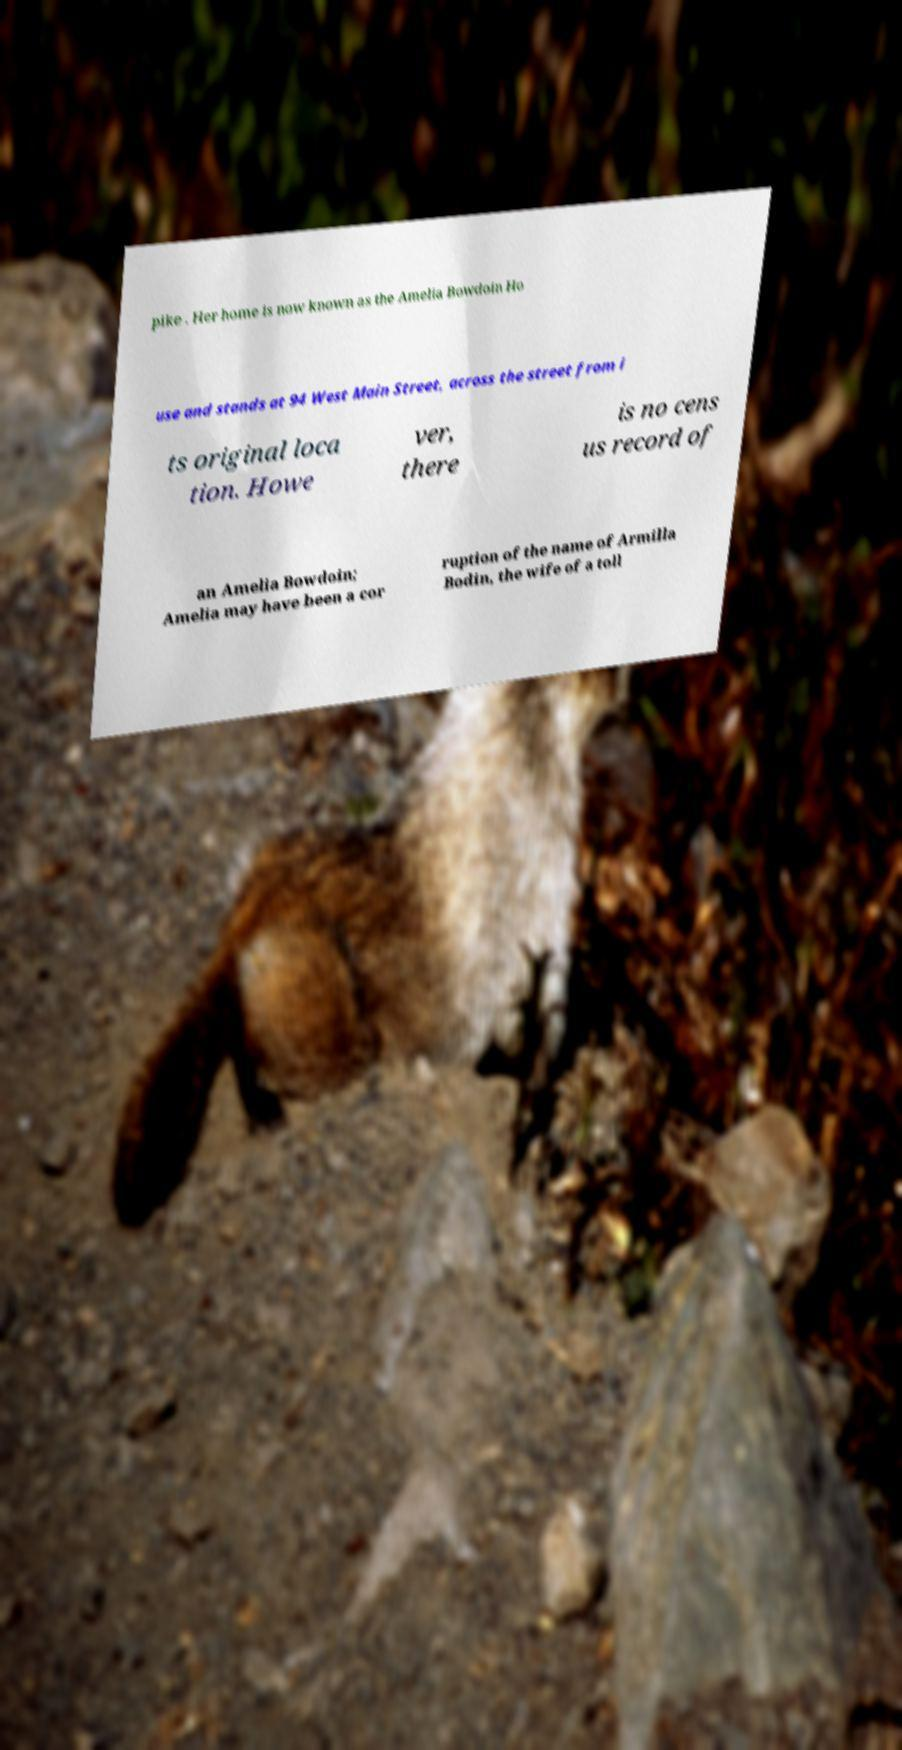Can you accurately transcribe the text from the provided image for me? pike . Her home is now known as the Amelia Bowdoin Ho use and stands at 94 West Main Street, across the street from i ts original loca tion. Howe ver, there is no cens us record of an Amelia Bowdoin; Amelia may have been a cor ruption of the name of Armilla Bodin, the wife of a toll 